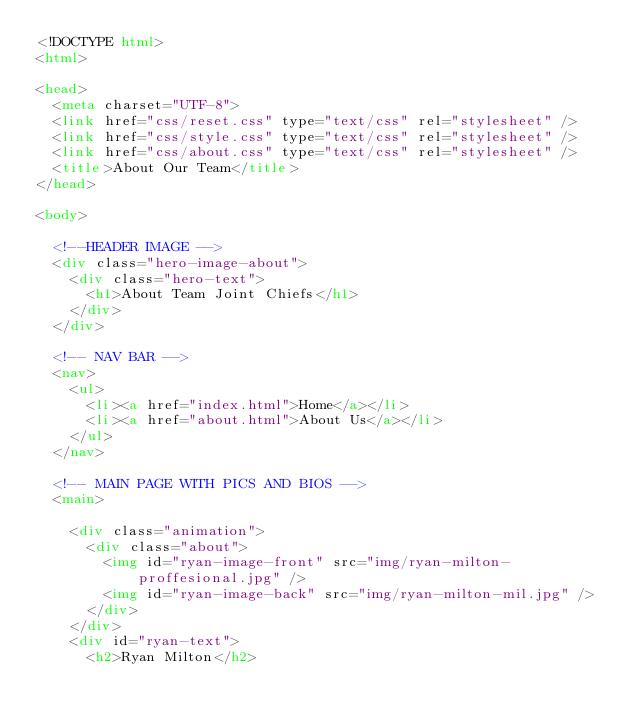Convert code to text. <code><loc_0><loc_0><loc_500><loc_500><_HTML_><!DOCTYPE html>
<html>

<head>
  <meta charset="UTF-8">
  <link href="css/reset.css" type="text/css" rel="stylesheet" />
  <link href="css/style.css" type="text/css" rel="stylesheet" />
  <link href="css/about.css" type="text/css" rel="stylesheet" />
  <title>About Our Team</title>
</head>

<body>

  <!--HEADER IMAGE -->
  <div class="hero-image-about">
    <div class="hero-text">
      <h1>About Team Joint Chiefs</h1>
    </div>
  </div>

  <!-- NAV BAR -->
  <nav>
    <ul>
      <li><a href="index.html">Home</a></li>
      <li><a href="about.html">About Us</a></li>
    </ul>
  </nav>

  <!-- MAIN PAGE WITH PICS AND BIOS -->
  <main>

    <div class="animation">
      <div class="about">
        <img id="ryan-image-front" src="img/ryan-milton-proffesional.jpg" />
        <img id="ryan-image-back" src="img/ryan-milton-mil.jpg" />
      </div>
    </div>
    <div id="ryan-text">
      <h2>Ryan Milton</h2></code> 